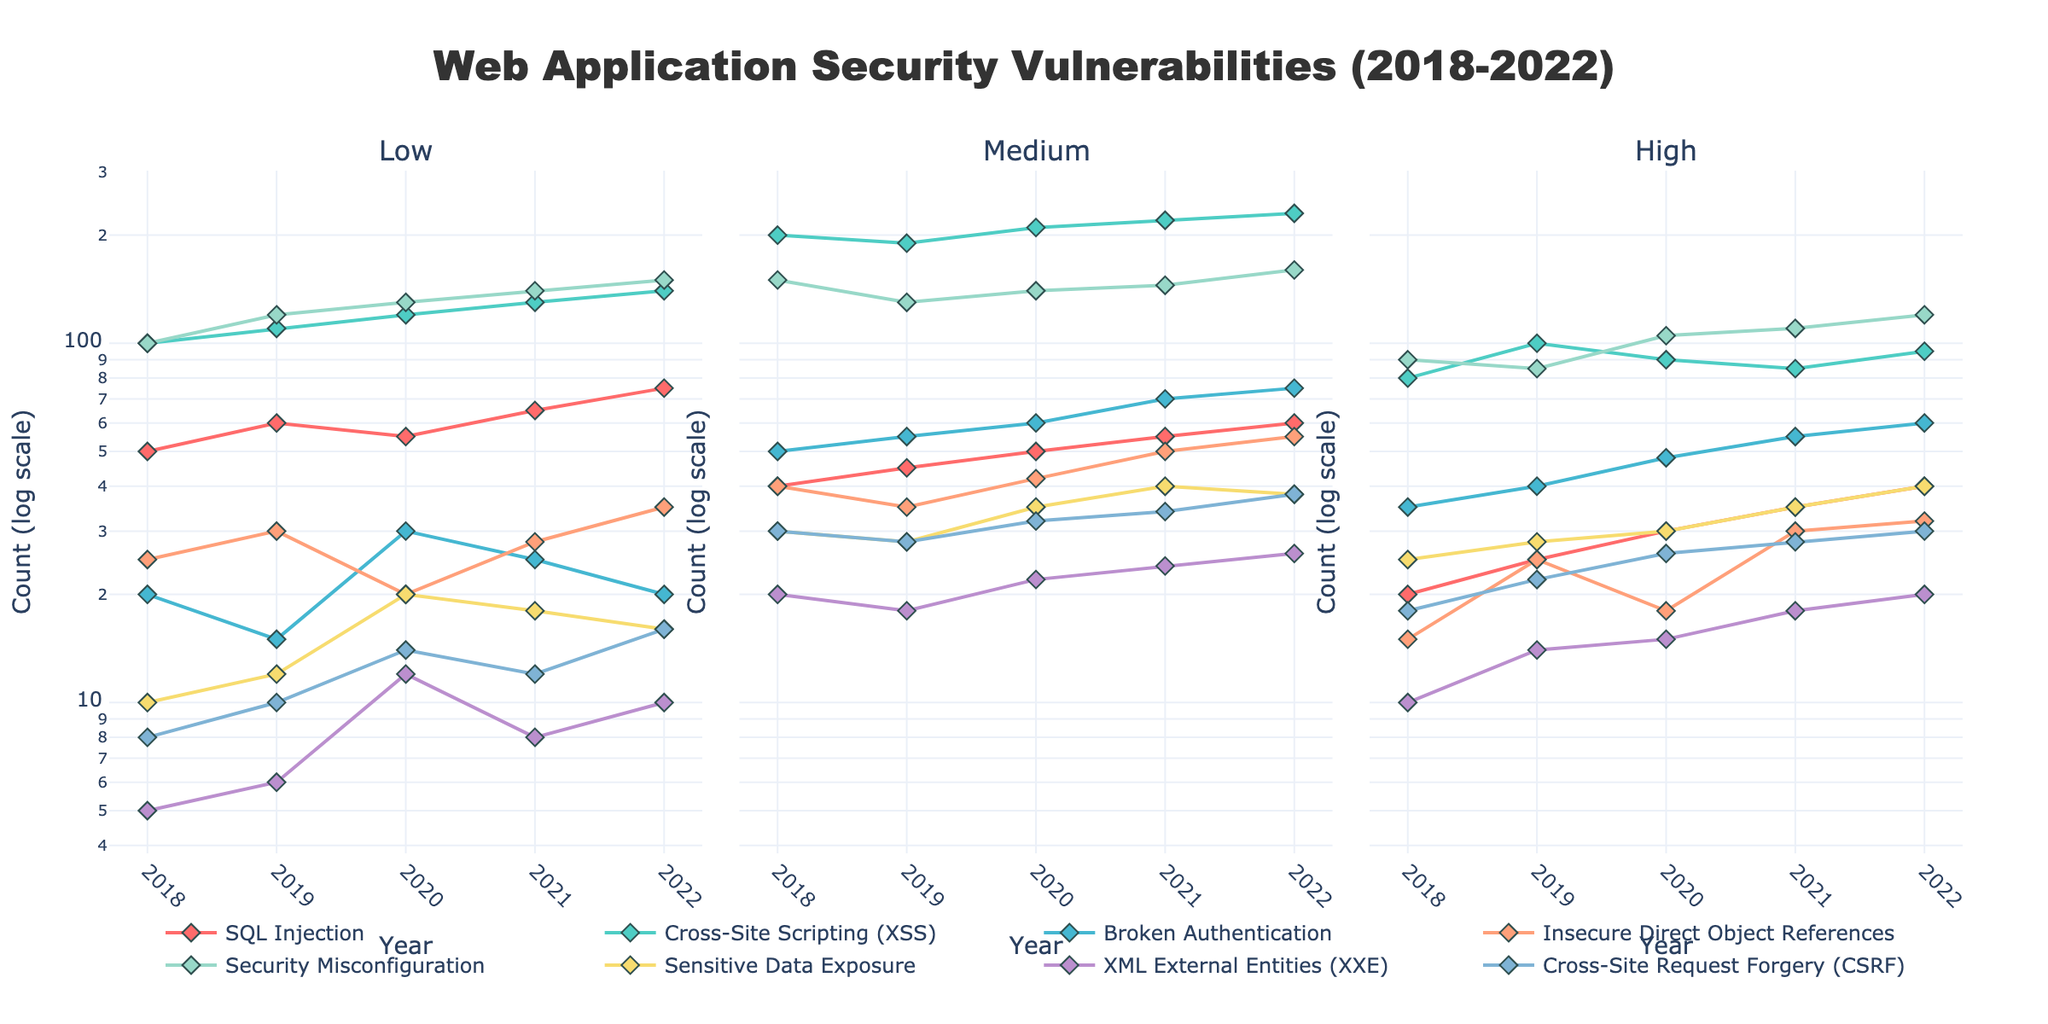What's the title of the figure? The title is always displayed at the top of the plot. In this case, it's located in the center above the plots.
Answer: Web Application Security Vulnerabilities (2018-2022) How many severity levels are shown in the figure? The figure includes subplots, each titled with a severity level. We see three subplot titles, each representing a different severity level.
Answer: 3 Which security vulnerability had the highest count in 2021 within the "High" severity category? Look at the subplot for the "High" severity in 2021 and compare the values of each type. The highest point on a log scale corresponds to "Security Misconfiguration."
Answer: Security Misconfiguration In which year did "Cross-Site Request Forgery (CSRF)" have the highest count within the "Medium" severity category? Observe the "Medium" severity subplot and follow the "CSRF" line through the years. The peak on the CSRF series indicates the year with the highest count.
Answer: 2022 What is the trend for "Broken Authentication" across the years within the "Low" severity category? Trace the line for "Broken Authentication" in the "Low" severity subplot from 2018 to 2022. The count sees a slight dip in 2019 and 2021 but generally varies without a clear linear increase or decrease.
Answer: Varied with no clear trend Compare the counts of "SQL Injection" and "Cross-Site Scripting (XSS)" in the "Low" severity category for the year 2020. Which one is higher? In the "Low" severity subplot, locate both "SQL Injection" and "XSS" points for the year 2020. Compare the two values, where "XSS" has a higher log-scale value.
Answer: Cross-Site Scripting (XSS) What was the average count of "Sensitive Data Exposure" in the "High" severity category from 2018 to 2022? Sum the values of "Sensitive Data Exposure" for the years 2018, 2019, 2020, 2021, and 2022 in the "High" severity category, and divide by 5.
Answer: 27.6 How many types of security vulnerabilities were tracked each year? Count the number of different types of vulnerabilities listed in any year-row of the dataset.
Answer: 8 What year had the least number of "XML External Entities (XXE)" vulnerabilities in the "Medium" severity category? Check the "Medium" severity subplot and track the "XXE" line. The lowest point corresponds to the year with the least count.
Answer: 2018 